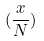Convert formula to latex. <formula><loc_0><loc_0><loc_500><loc_500>( \frac { x } { N } )</formula> 